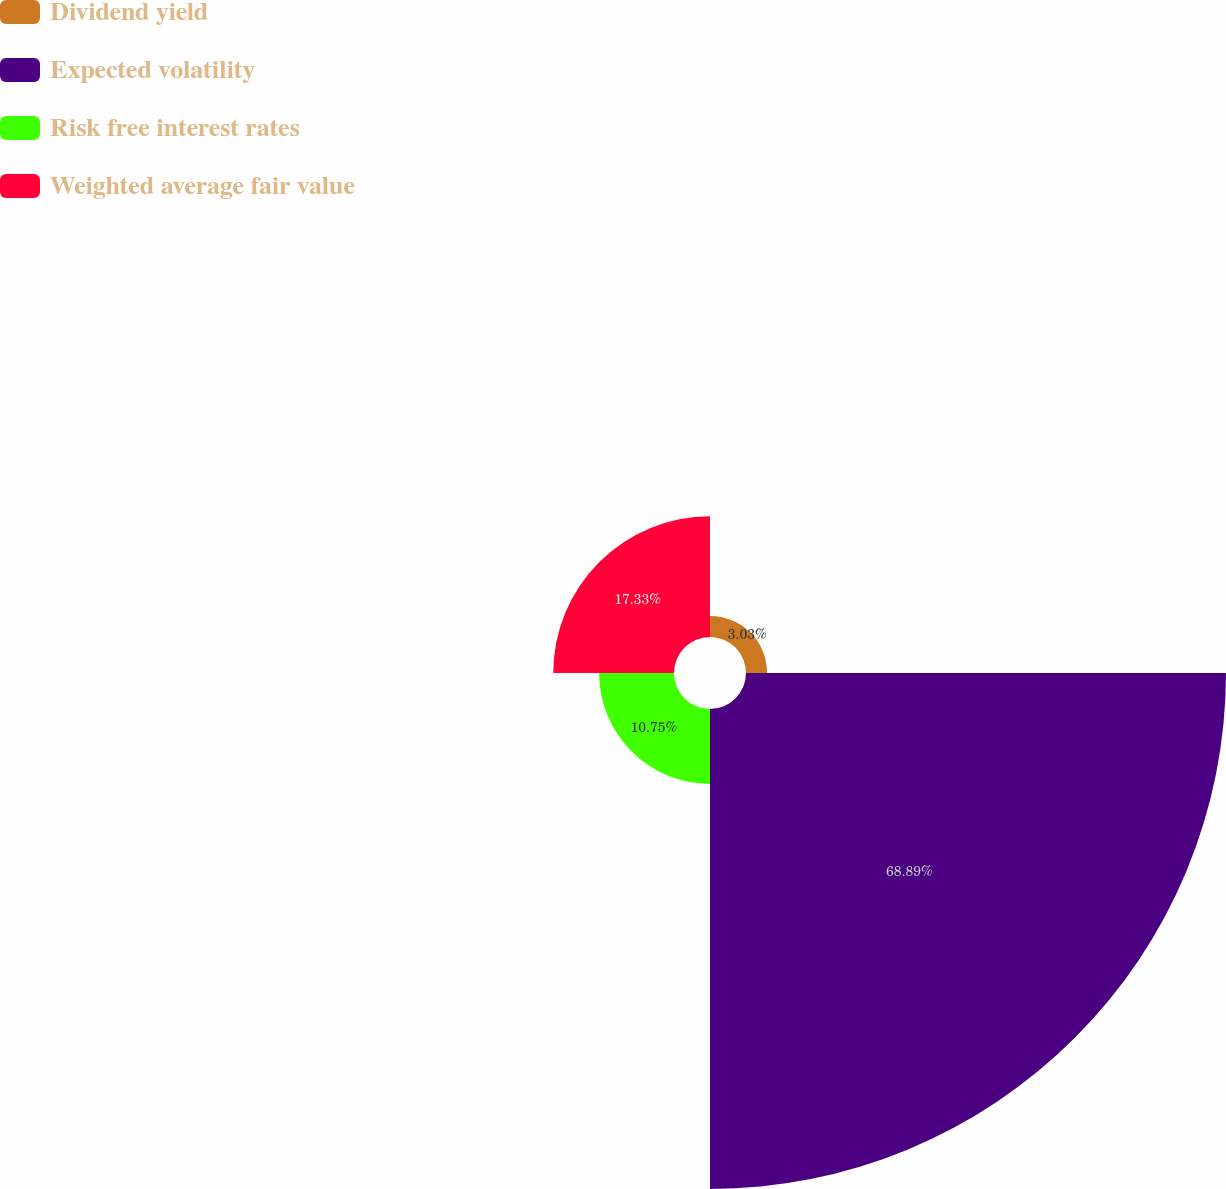Convert chart to OTSL. <chart><loc_0><loc_0><loc_500><loc_500><pie_chart><fcel>Dividend yield<fcel>Expected volatility<fcel>Risk free interest rates<fcel>Weighted average fair value<nl><fcel>3.03%<fcel>68.89%<fcel>10.75%<fcel>17.33%<nl></chart> 